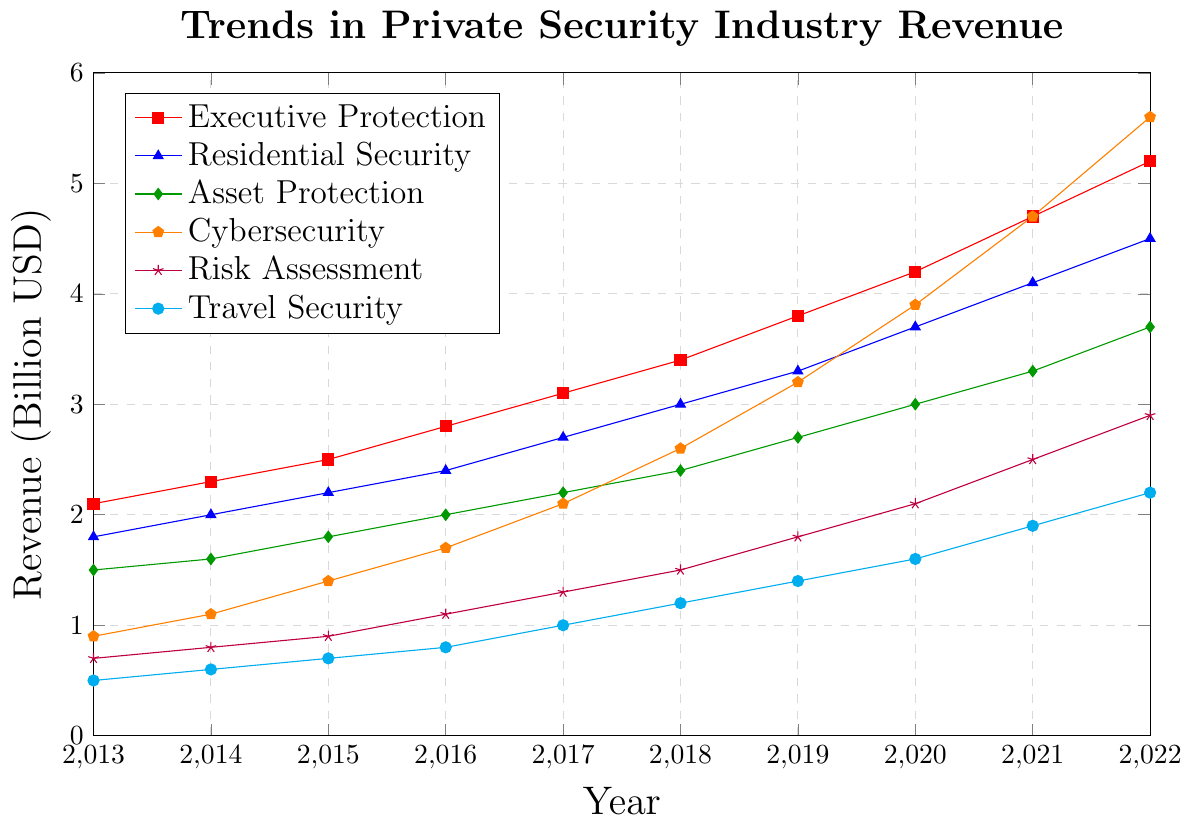What service had the highest revenue in 2022? To find the answer, look at the figure and identify the service type with the highest data point in 2022. The highest point is at 5.6 billion USD, which corresponds to Cybersecurity.
Answer: Cybersecurity By how much did the revenue for Residential Security increase from 2013 to 2022? First, find the revenue for Residential Security in 2013 and 2022 from the figure. In 2013, it was 1.8 billion USD, and in 2022, it was 4.5 billion USD. Subtract the 2013 value from the 2022 value: 4.5 - 1.8 = 2.7 billion USD.
Answer: 2.7 billion USD Which service showed the most growth between 2018 and 2022? Look for the service that has the largest increase in revenue between 2018 and 2022. Subtract the 2018 revenue from the 2022 revenue for each service and compare:
- Executive Protection: 5.2 - 3.4 = 1.8
- Residential Security: 4.5 - 3.0 = 1.5
- Asset Protection: 3.7 - 2.4 = 1.3
- Cybersecurity: 5.6 - 2.6 = 3.0
- Risk Assessment: 2.9 - 1.5 = 1.4
- Travel Security: 2.2 - 1.2 = 1.0
Cybersecurity had the highest growth of 3.0 billion USD.
Answer: Cybersecurity What is the average revenue for Asset Protection over the decade? To find the average, add the revenues for Asset Protection from 2013 to 2022 and divide by the number of years (10):
(1.5 + 1.6 + 1.8 + 2.0 + 2.2 + 2.4 + 2.7 + 3.0 + 3.3 + 3.7) / 10 = 24.2 / 10 = 2.42 billion USD.
Answer: 2.42 billion USD In 2020, how did the revenue from Travel Security compare to Risk Assessment? Look at the figure to find the revenues for Travel Security and Risk Assessment in 2020. Travel Security was 1.6 billion USD, and Risk Assessment was 2.1 billion USD. Comparing the two, Risk Assessment had a higher revenue.
Answer: Risk Assessment is higher Which service had the smallest revenue in 2019? Identify the service with the smallest data point in 2019 from the figure. The smallest value is at 1.4 billion USD, which corresponds to Travel Security.
Answer: Travel Security What was the total revenue for all services combined in 2017? Add the revenues for all services in 2017:
3.1 (Executive Protection) + 2.7 (Residential Security) + 2.2 (Asset Protection) + 2.1 (Cybersecurity) + 1.3 (Risk Assessment) + 1.0 (Travel Security) = 12.4 billion USD.
Answer: 12.4 billion USD What was the median revenue for Risk Assessment between 2013 and 2022? To find the median, list the revenues for Risk Assessment from 2013 to 2022 and find the middle value. The revenues are: 0.7, 0.8, 0.9, 1.1, 1.3, 1.5, 1.8, 2.1, 2.5, 2.9. Since there are 10 data points, the median is the average of the 5th and 6th values: (1.3 + 1.5) / 2 = 1.4 billion USD.
Answer: 1.4 billion USD 